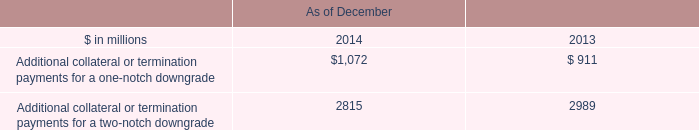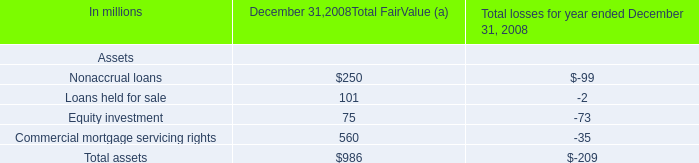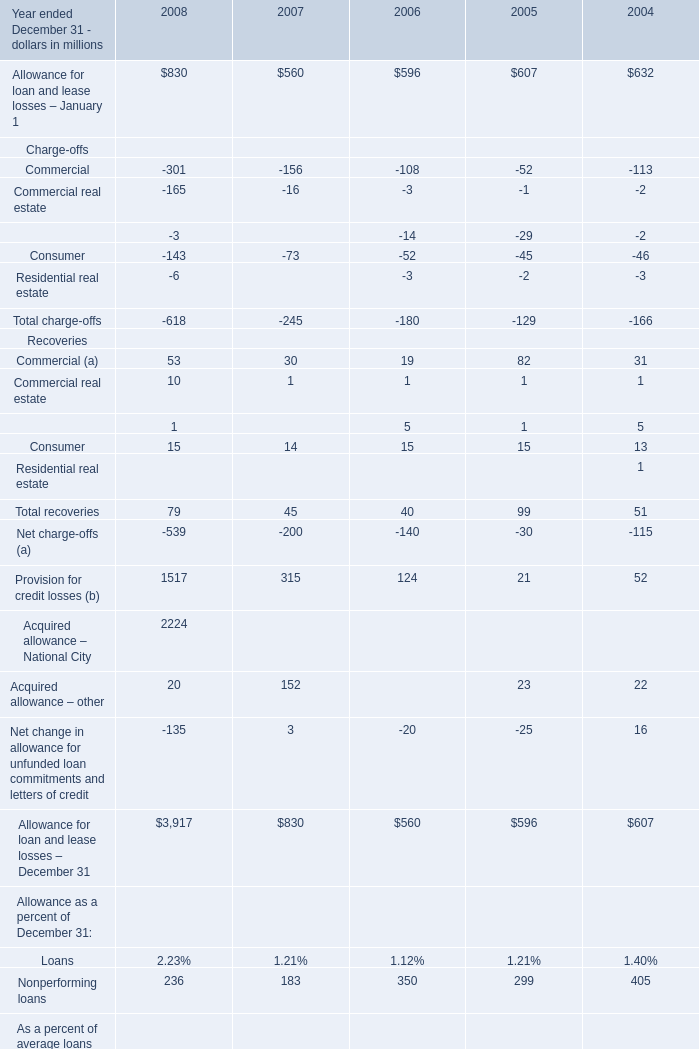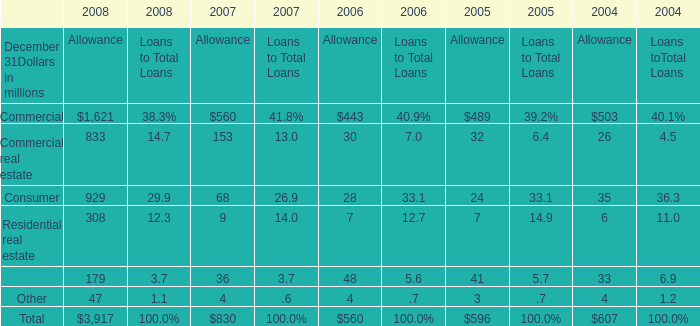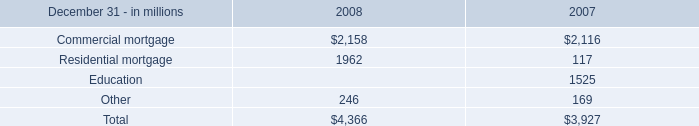In the year with the most Commercial, what is the growth rate of Residential real estate? 
Computations: ((308 - 9) / 308)
Answer: 0.97078. 